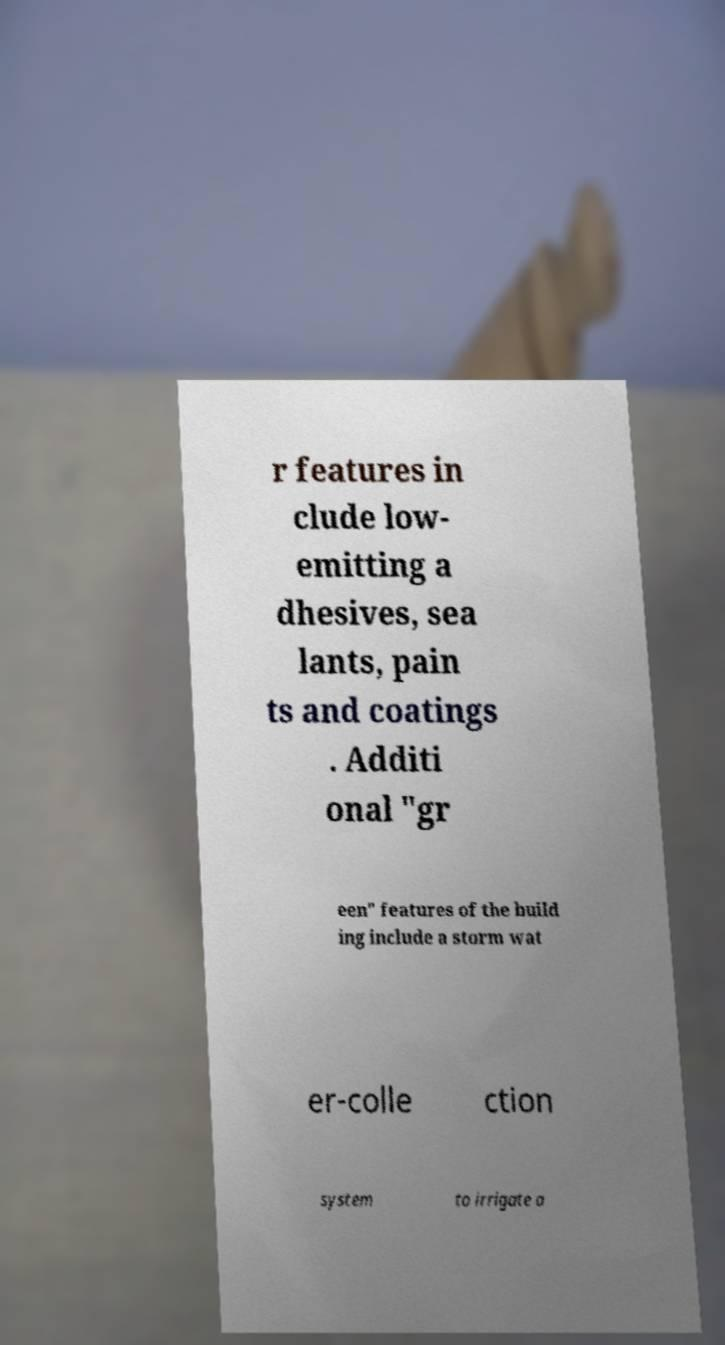What messages or text are displayed in this image? I need them in a readable, typed format. r features in clude low- emitting a dhesives, sea lants, pain ts and coatings . Additi onal "gr een" features of the build ing include a storm wat er-colle ction system to irrigate a 